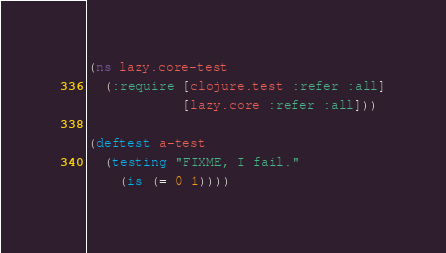<code> <loc_0><loc_0><loc_500><loc_500><_Clojure_>(ns lazy.core-test
  (:require [clojure.test :refer :all]
            [lazy.core :refer :all]))

(deftest a-test
  (testing "FIXME, I fail."
    (is (= 0 1))))
</code> 